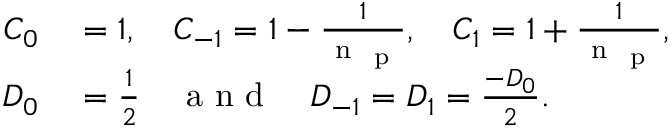<formula> <loc_0><loc_0><loc_500><loc_500>\begin{array} { r l } { C _ { 0 } } & = 1 , \quad C _ { - 1 } = 1 - \frac { 1 } { n _ { p } } , \quad C _ { 1 } = 1 + \frac { 1 } { n _ { p } } , } \\ { D _ { 0 } } & = \frac { 1 } { 2 } \quad a n d \quad D _ { - 1 } = D _ { 1 } = \frac { - D _ { 0 } } { 2 } . } \end{array}</formula> 